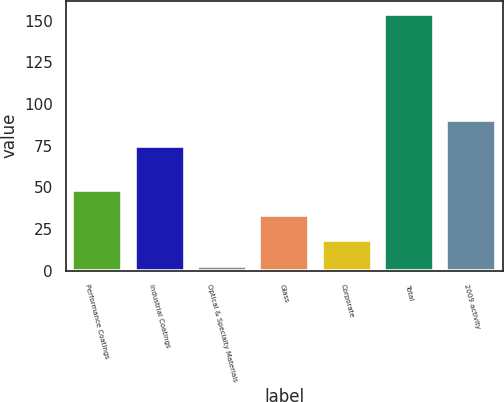Convert chart. <chart><loc_0><loc_0><loc_500><loc_500><bar_chart><fcel>Performance Coatings<fcel>Industrial Coatings<fcel>Optical & Specialty Materials<fcel>Glass<fcel>Corporate<fcel>Total<fcel>2009 activity<nl><fcel>48.3<fcel>75<fcel>3<fcel>33.2<fcel>18.1<fcel>154<fcel>90.1<nl></chart> 